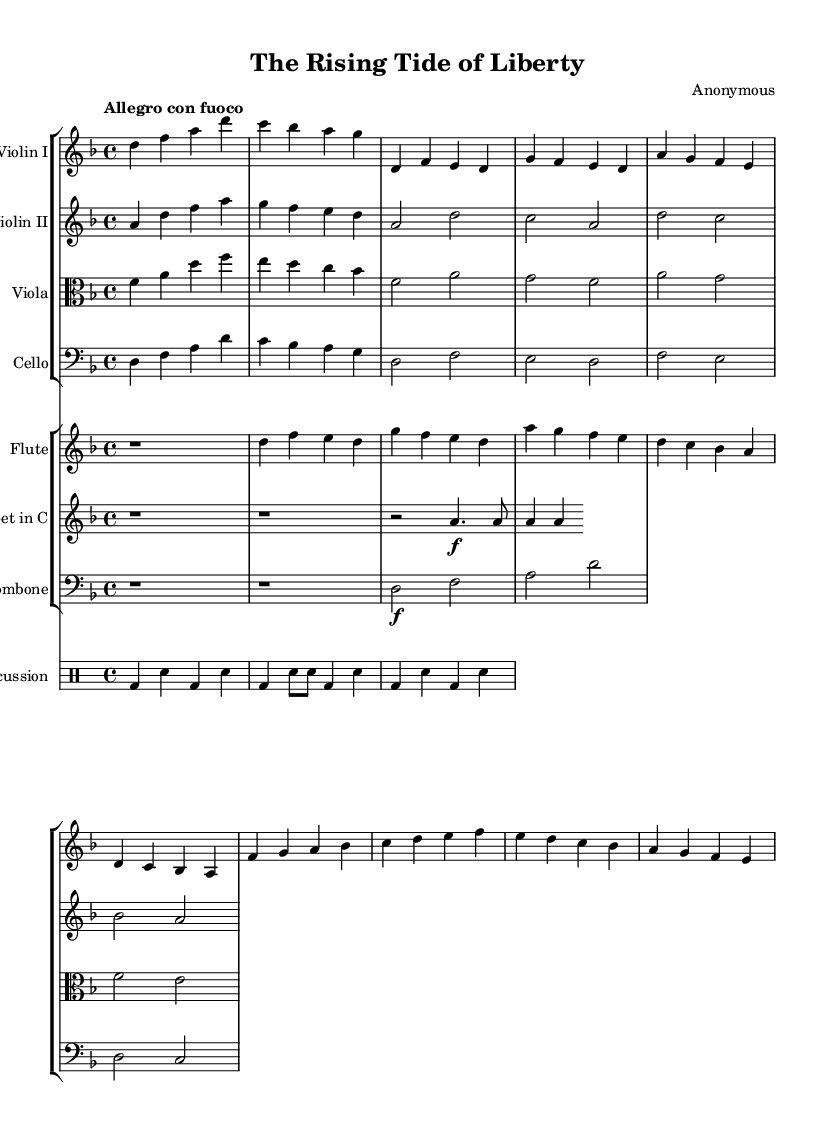What is the key signature of this music? The key signature is indicated at the beginning of the staff lines. In this sheet music, there is one flat (B flat) shown after the clef sign, indicating that the key signature is D minor.
Answer: D minor What is the time signature of this composition? The time signature is found right after the key signature at the beginning of the sheet music. Here, it is indicated as 4/4, meaning there are four beats per measure and the quarter note receives one beat.
Answer: 4/4 What tempo marking is given for this piece? The tempo marking is specified near the beginning of the music sheet, using Italian terms. In this sheet, "Allegro con fuoco" indicates a fast tempo with fire, suggesting an energetic performance.
Answer: Allegro con fuoco Which instruments play the introductory measures? By examining the score layout, we can observe the parts that are present in the initial measures. The introduction is played by the Violin I and Flute sections, as they have the melodic lines during that section.
Answer: Violin I and Flute What is the primary theme's note sequence in the Violin I part? Analyzing the Violin I part, we can find the note sequence for the primary theme marked 'Theme A'. This theme begins with notes d, f, e, d, g, f, e, d, and extends further, but the initial sequence is enough to identify it.
Answer: d, f, e, d, g, f, e, d How many measures are present in the provided score? To find the total number of measures, we count each set of vertical bar lines in the score. This score breaks the music into distinct measures, and upon counting, we find there are 12 distinct measures presented.
Answer: 12 What instrumental ensemble is featured in this composition? By inspecting the score layout, we notice the composition includes multiple string instruments (violins, viola, cello), wind instruments (flute, trumpet, trombone), and percussion (drums). This arrangement denotes a chamber orchestra structure.
Answer: Chamber orchestra 